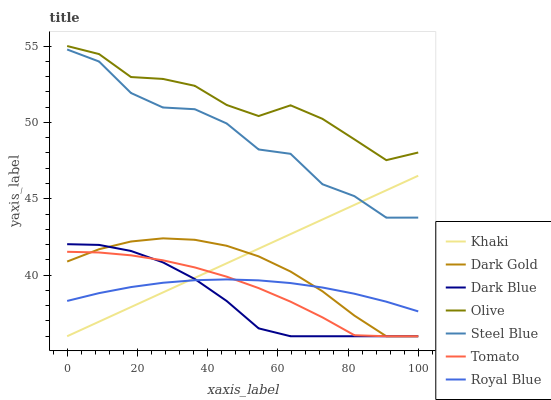Does Dark Blue have the minimum area under the curve?
Answer yes or no. Yes. Does Olive have the maximum area under the curve?
Answer yes or no. Yes. Does Khaki have the minimum area under the curve?
Answer yes or no. No. Does Khaki have the maximum area under the curve?
Answer yes or no. No. Is Khaki the smoothest?
Answer yes or no. Yes. Is Steel Blue the roughest?
Answer yes or no. Yes. Is Royal Blue the smoothest?
Answer yes or no. No. Is Royal Blue the roughest?
Answer yes or no. No. Does Royal Blue have the lowest value?
Answer yes or no. No. Does Olive have the highest value?
Answer yes or no. Yes. Does Khaki have the highest value?
Answer yes or no. No. Is Dark Gold less than Olive?
Answer yes or no. Yes. Is Olive greater than Dark Gold?
Answer yes or no. Yes. Does Dark Gold intersect Dark Blue?
Answer yes or no. Yes. Is Dark Gold less than Dark Blue?
Answer yes or no. No. Is Dark Gold greater than Dark Blue?
Answer yes or no. No. Does Dark Gold intersect Olive?
Answer yes or no. No. 